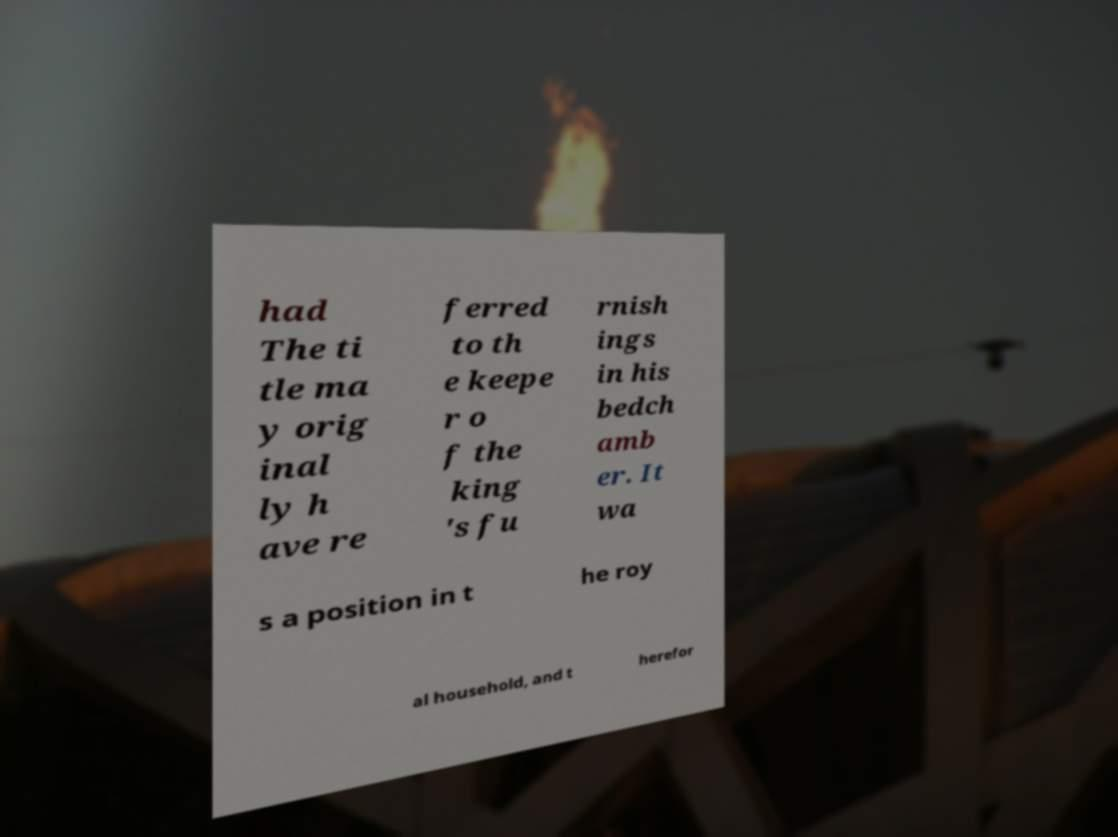There's text embedded in this image that I need extracted. Can you transcribe it verbatim? had The ti tle ma y orig inal ly h ave re ferred to th e keepe r o f the king 's fu rnish ings in his bedch amb er. It wa s a position in t he roy al household, and t herefor 